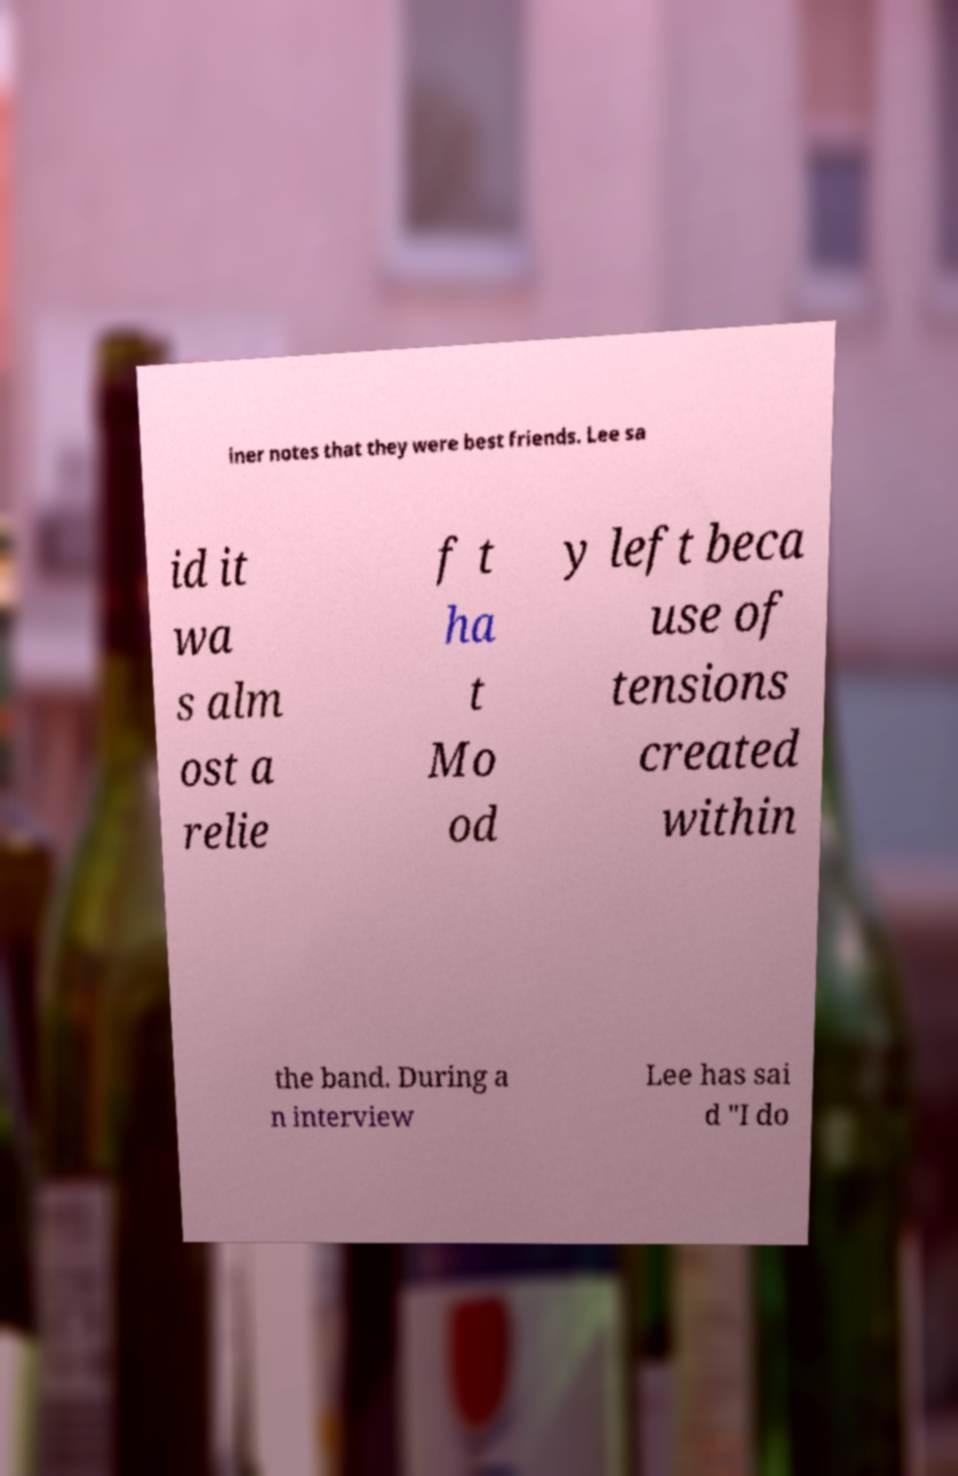For documentation purposes, I need the text within this image transcribed. Could you provide that? iner notes that they were best friends. Lee sa id it wa s alm ost a relie f t ha t Mo od y left beca use of tensions created within the band. During a n interview Lee has sai d "I do 